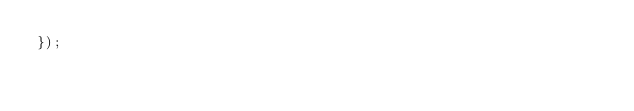Convert code to text. <code><loc_0><loc_0><loc_500><loc_500><_TypeScript_>});
</code> 